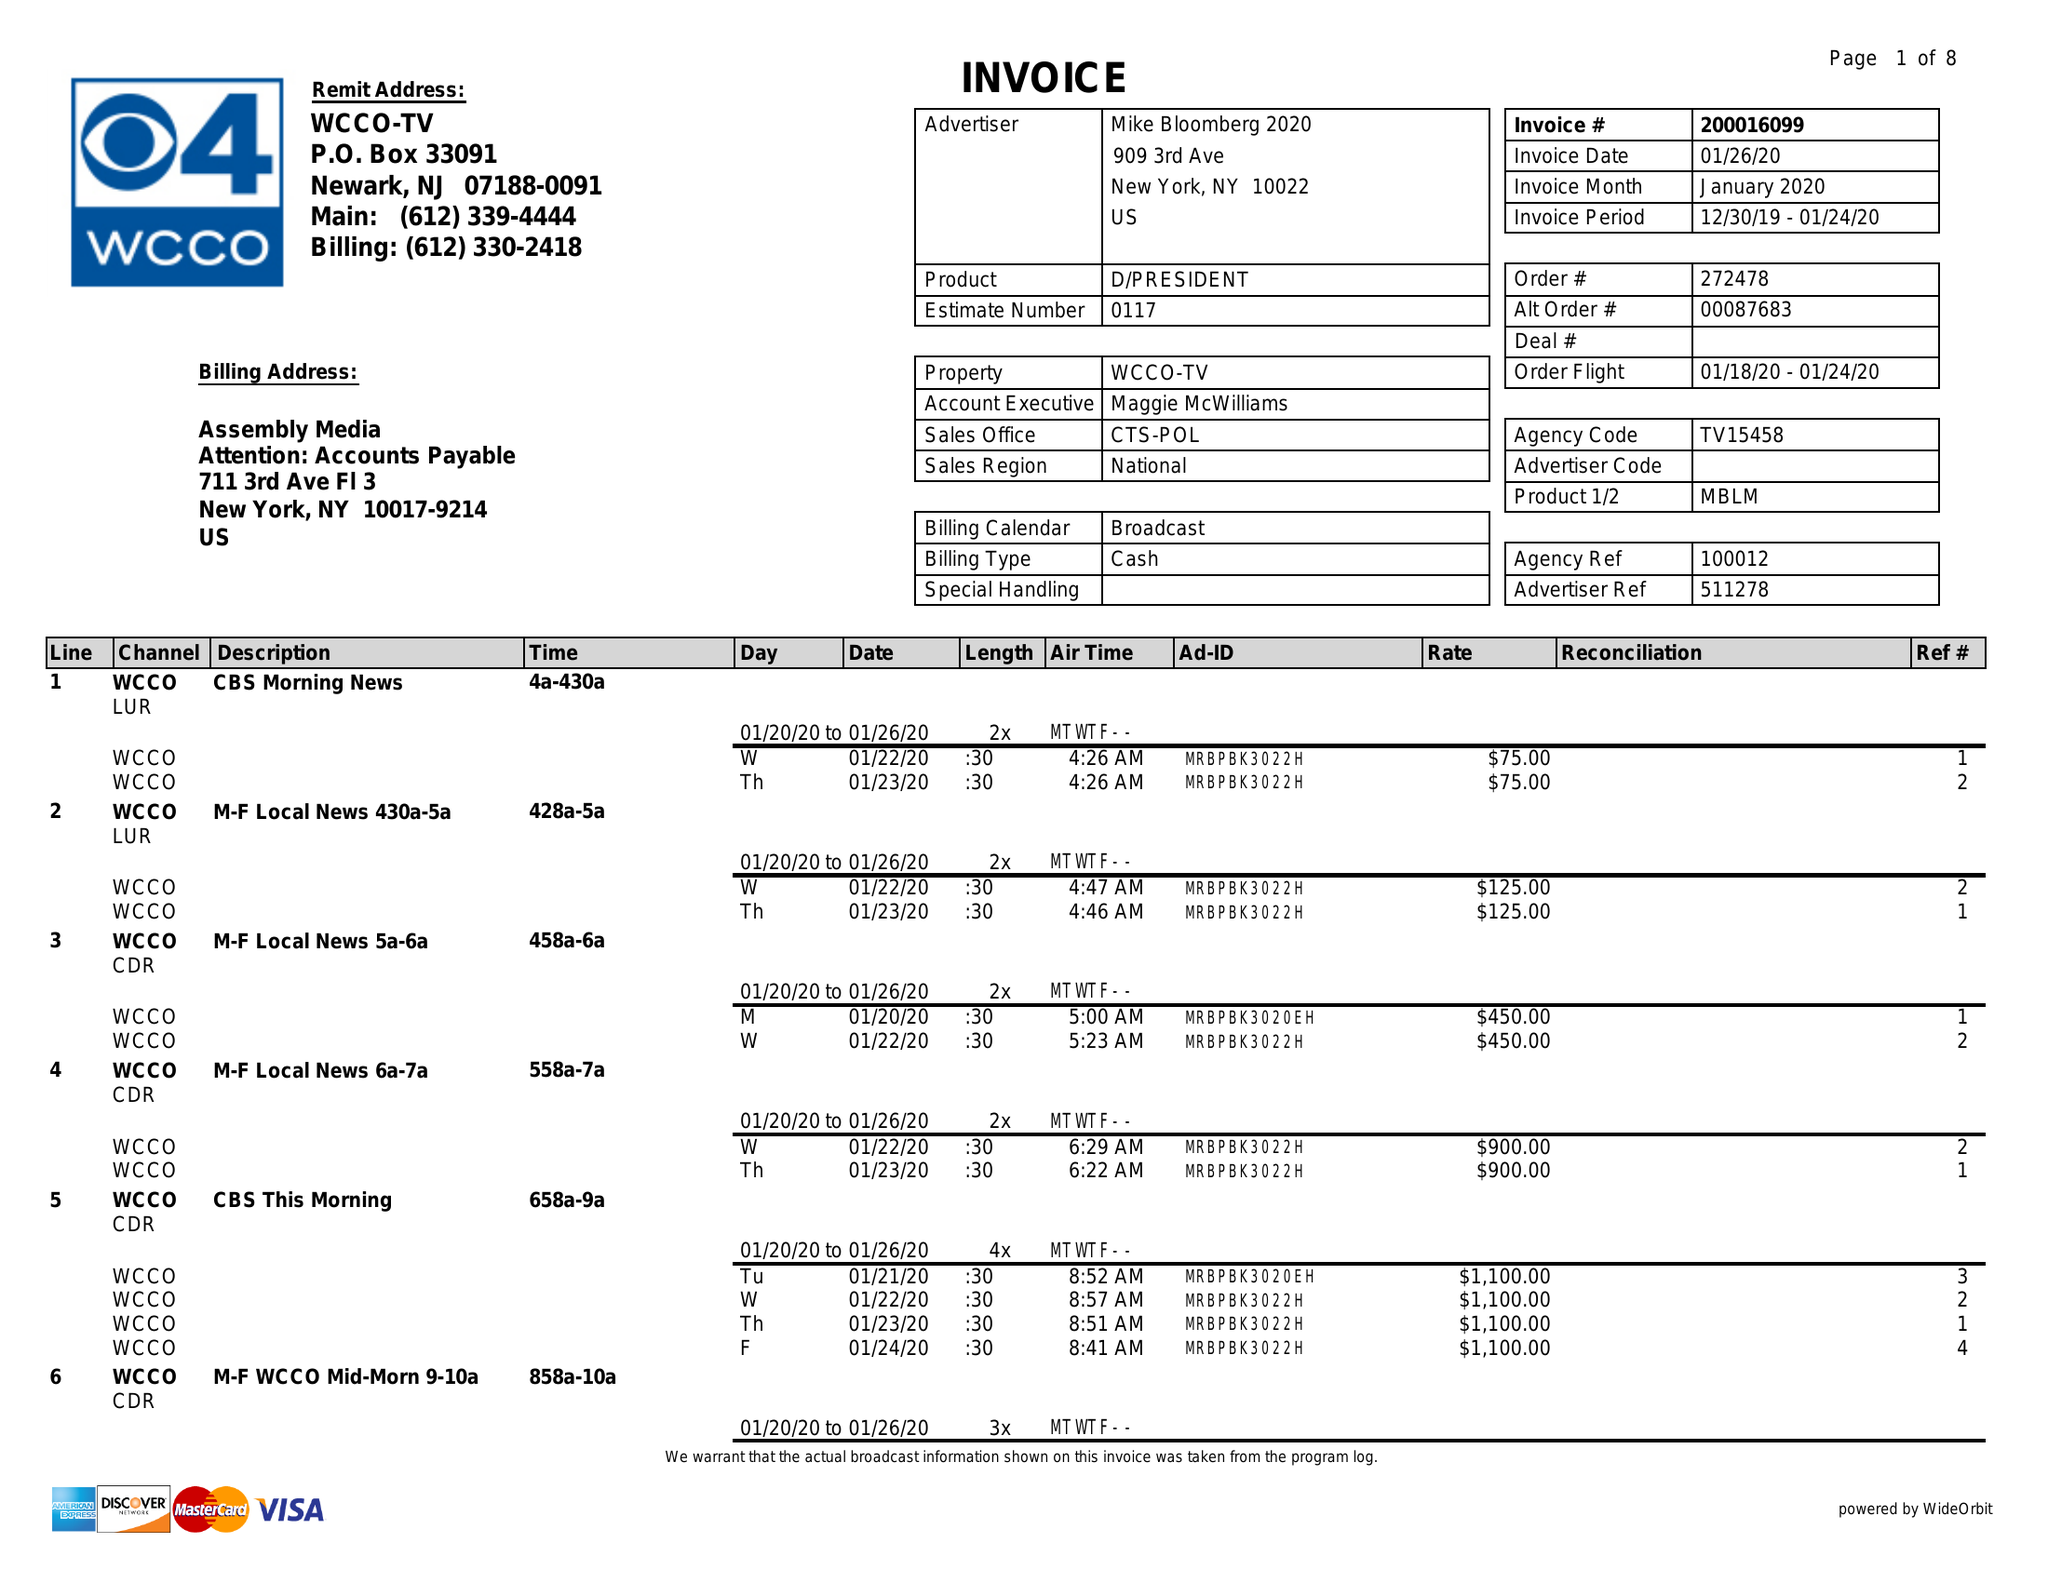What is the value for the flight_to?
Answer the question using a single word or phrase. 01/24/20 